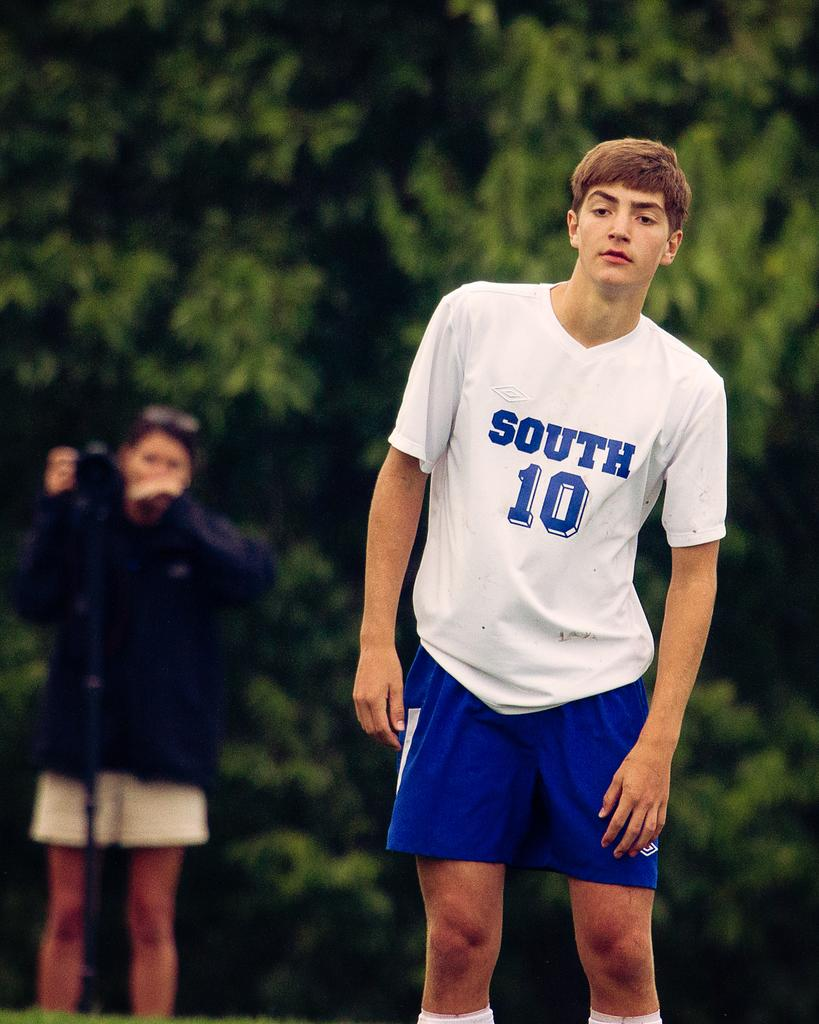<image>
Give a short and clear explanation of the subsequent image. A sportsman wearing a shirt with the word South written on it looks past the camera. 